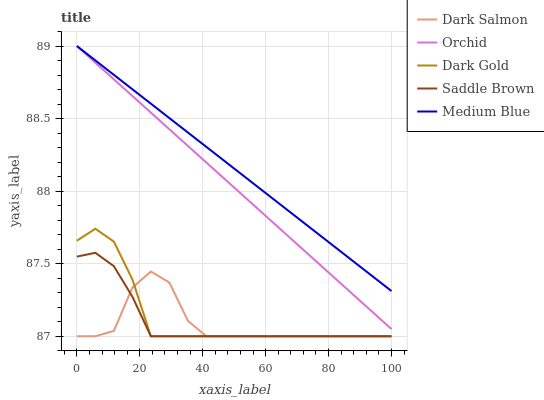Does Dark Salmon have the minimum area under the curve?
Answer yes or no. Yes. Does Medium Blue have the maximum area under the curve?
Answer yes or no. Yes. Does Dark Gold have the minimum area under the curve?
Answer yes or no. No. Does Dark Gold have the maximum area under the curve?
Answer yes or no. No. Is Orchid the smoothest?
Answer yes or no. Yes. Is Dark Salmon the roughest?
Answer yes or no. Yes. Is Dark Gold the smoothest?
Answer yes or no. No. Is Dark Gold the roughest?
Answer yes or no. No. Does Saddle Brown have the lowest value?
Answer yes or no. Yes. Does Medium Blue have the lowest value?
Answer yes or no. No. Does Orchid have the highest value?
Answer yes or no. Yes. Does Dark Gold have the highest value?
Answer yes or no. No. Is Dark Salmon less than Medium Blue?
Answer yes or no. Yes. Is Medium Blue greater than Dark Salmon?
Answer yes or no. Yes. Does Saddle Brown intersect Dark Gold?
Answer yes or no. Yes. Is Saddle Brown less than Dark Gold?
Answer yes or no. No. Is Saddle Brown greater than Dark Gold?
Answer yes or no. No. Does Dark Salmon intersect Medium Blue?
Answer yes or no. No. 